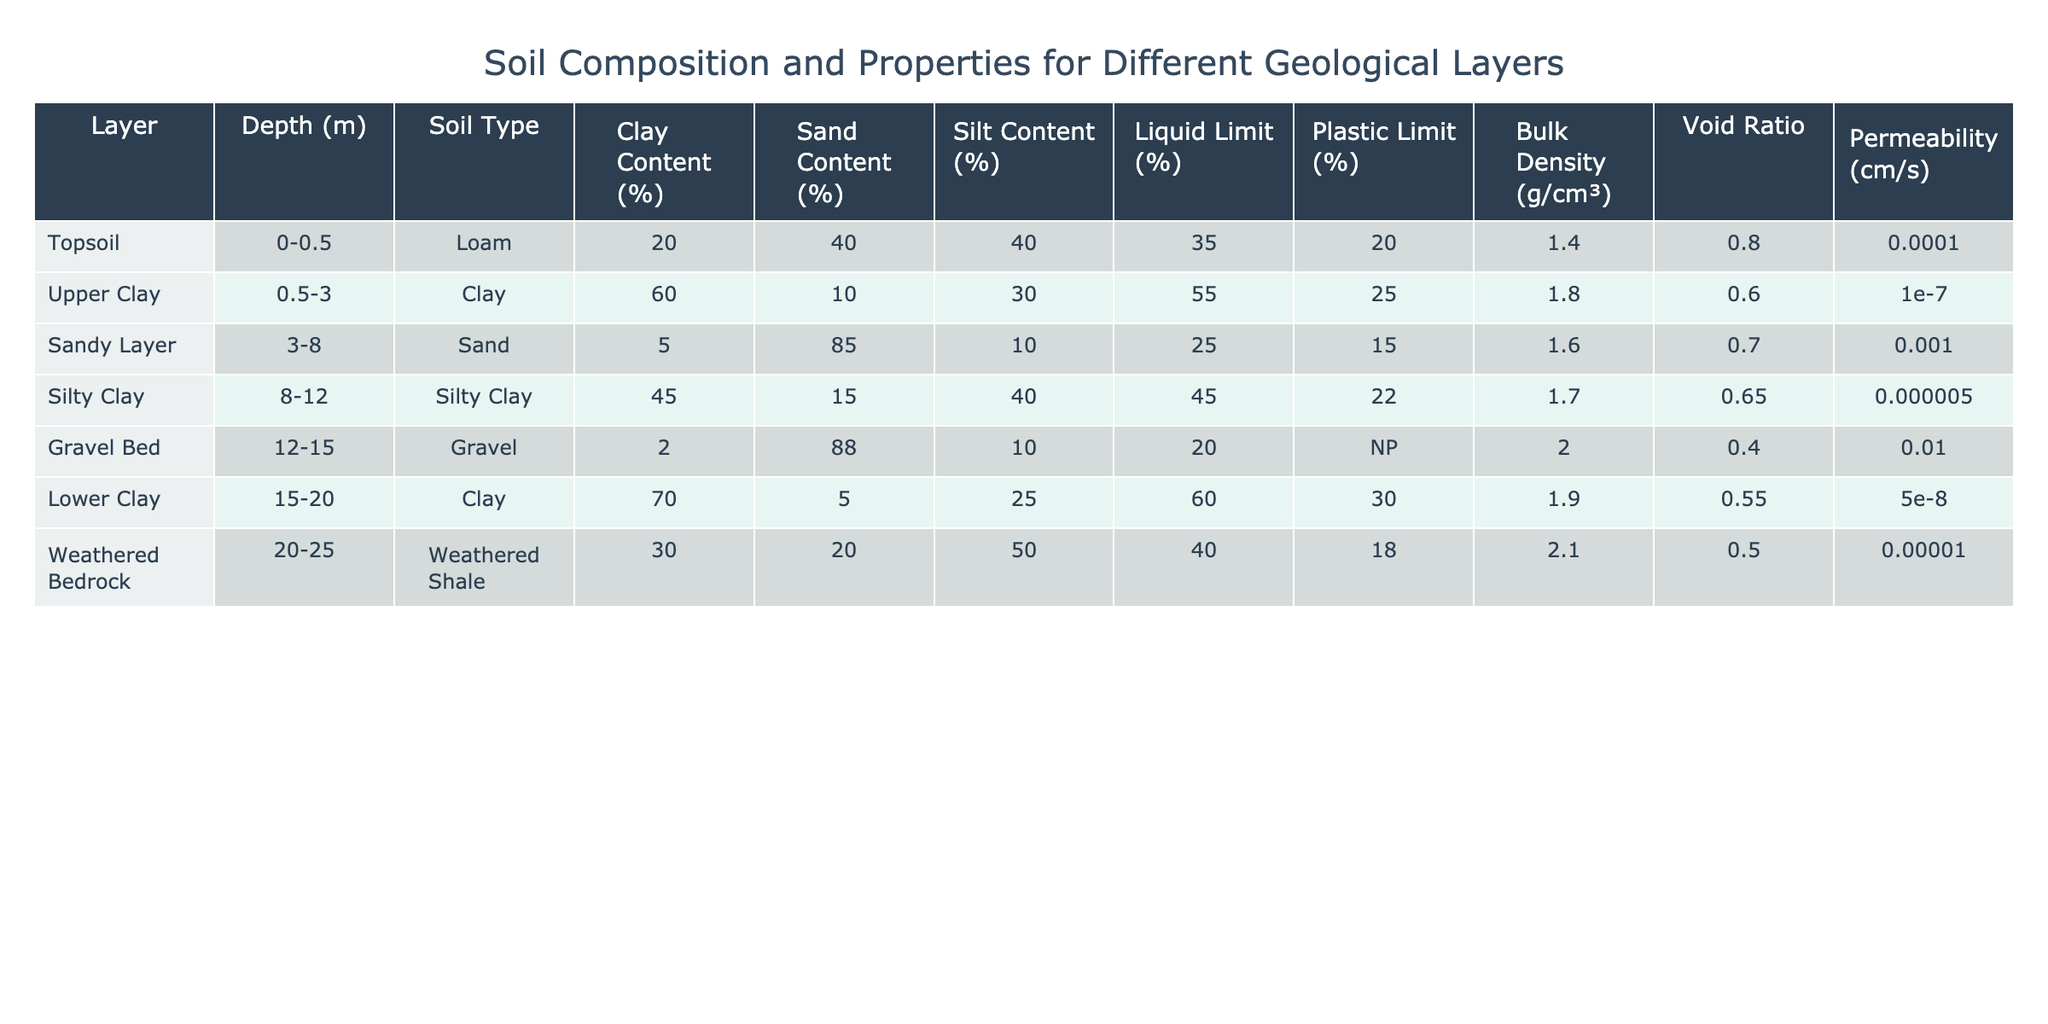What is the clay content of the Upper Clay layer? The Upper Clay layer has a clay content of 60%, as directly listed in the table.
Answer: 60% What is the depth range of the Sandy Layer? The Sandy Layer is found between 3 and 8 meters deep, as indicated in the table under the Depth column.
Answer: 3-8 m Which soil type has the highest sand content? The Sandy Layer, which consists of Sand, has the highest sand content at 85%, according to the table.
Answer: Sand Is the Liquid Limit for the Gravel Bed greater than that for the Silty Clay? The Liquid Limit for the Gravel Bed is 20% and for the Silty Clay is 45%. Since 20% is less than 45%, the statement is false.
Answer: No What is the average clay content across all layers? To find the average clay content, sum all the clay percentages (20 + 60 + 5 + 45 + 2 + 70 + 30 = 232) and divide by the number of layers (7). So, the average is 232 / 7 = 33.14.
Answer: 33.14% Which layer has the highest bulk density, and what is its value? The layer with the highest bulk density is the Weathered Bedrock, with a value of 2.1 g/cm³, as shown in the Bulk Density column.
Answer: Weathered Bedrock, 2.1 g/cm³ What is the difference in permeability between the Sandy Layer and the Upper Clay layer? The permeability of the Sandy Layer is 1.0e-3 cm/s, and for the Upper Clay Layer, it is 1.0e-7 cm/s. The difference is 1.0e-3 - 1.0e-7 = 0.000999 cm/s.
Answer: 0.000999 cm/s Do any of the layers have a void ratio greater than 1? By examining the Void Ratio column, the Topsoil (0.8), Upper Clay (0.6), Sandy Layer (0.7), Silty Clay (0.65), Gravel Bed (0.4), Lower Clay (0.55), and Weathered Bedrock (0.5) are all below 1. Thus, none of the layers have a void ratio greater than 1.
Answer: No Which layer has the highest Plastic Limit and what is the value? The layer with the highest Plastic Limit is the Lower Clay, with a value of 30%, as seen in the Plastic Limit column.
Answer: Lower Clay, 30% How does the clay content of the Lower Clay layer compare to that of the Upper Clay layer? The Lower Clay layer has a clay content of 70%, while the Upper Clay layer has 60%. Therefore, the Lower Clay layer has a higher clay content by 10%.
Answer: Higher by 10% 